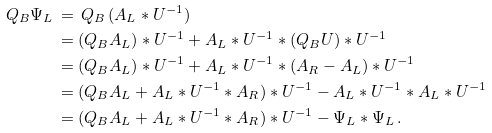Convert formula to latex. <formula><loc_0><loc_0><loc_500><loc_500>Q _ { B } \Psi _ { L } \, & = \, Q _ { B } \, ( A _ { L } \ast U ^ { - 1 } ) \\ & = ( Q _ { B } A _ { L } ) \ast U ^ { - 1 } + A _ { L } \ast U ^ { - 1 } \ast ( Q _ { B } U ) \ast U ^ { - 1 } \\ & = ( Q _ { B } A _ { L } ) \ast U ^ { - 1 } + A _ { L } \ast U ^ { - 1 } \ast ( A _ { R } - A _ { L } ) \ast U ^ { - 1 } \\ & = ( Q _ { B } A _ { L } + A _ { L } \ast U ^ { - 1 } \ast A _ { R } ) \ast U ^ { - 1 } - A _ { L } \ast U ^ { - 1 } \ast A _ { L } \ast U ^ { - 1 } \\ & = ( Q _ { B } A _ { L } + A _ { L } \ast U ^ { - 1 } \ast A _ { R } ) \ast U ^ { - 1 } - \Psi _ { L } \ast \Psi _ { L } \, .</formula> 